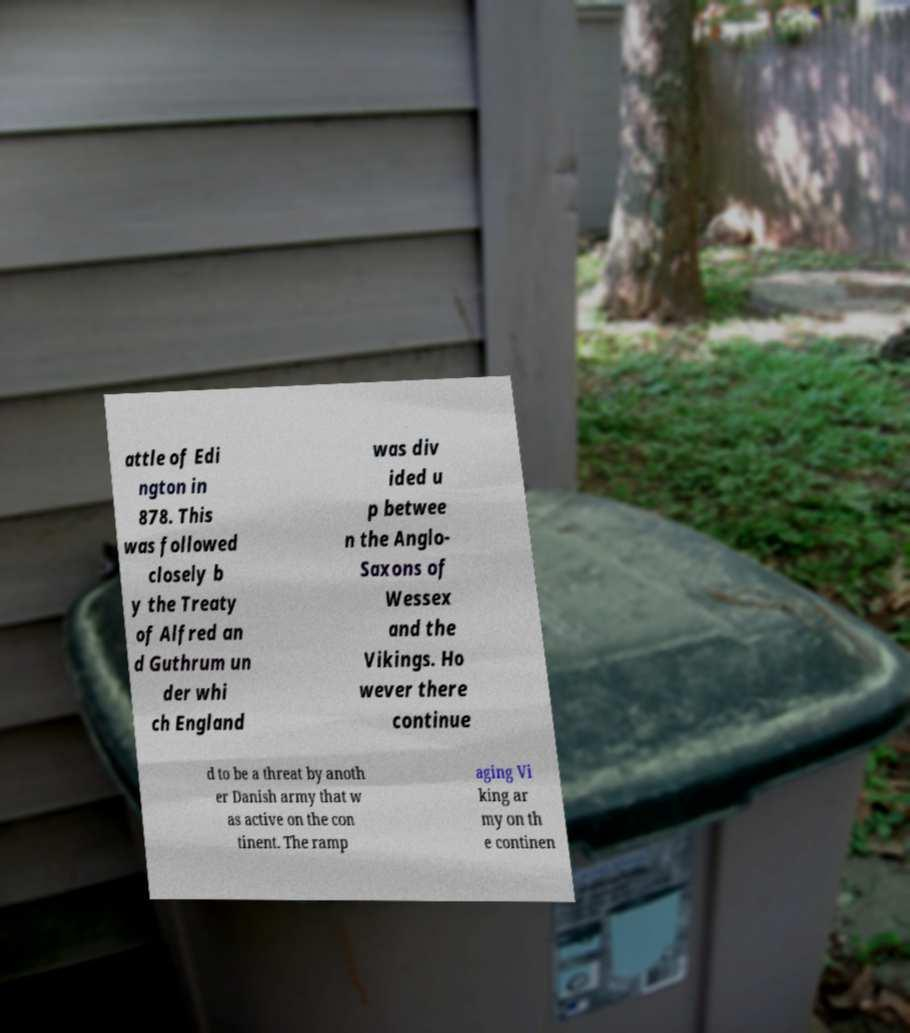Could you assist in decoding the text presented in this image and type it out clearly? attle of Edi ngton in 878. This was followed closely b y the Treaty of Alfred an d Guthrum un der whi ch England was div ided u p betwee n the Anglo- Saxons of Wessex and the Vikings. Ho wever there continue d to be a threat by anoth er Danish army that w as active on the con tinent. The ramp aging Vi king ar my on th e continen 